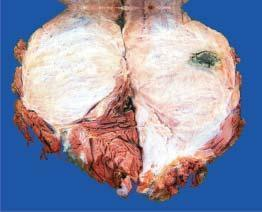s iron somewhat circumscribed?
Answer the question using a single word or phrase. No 